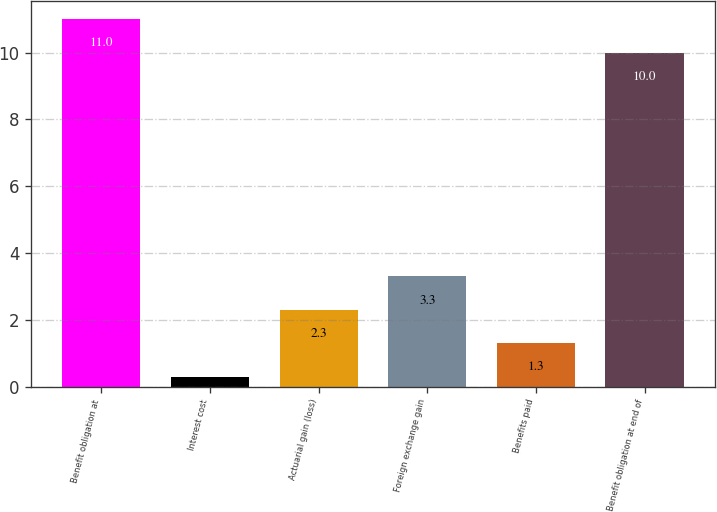Convert chart. <chart><loc_0><loc_0><loc_500><loc_500><bar_chart><fcel>Benefit obligation at<fcel>Interest cost<fcel>Actuarial gain (loss)<fcel>Foreign exchange gain<fcel>Benefits paid<fcel>Benefit obligation at end of<nl><fcel>11<fcel>0.3<fcel>2.3<fcel>3.3<fcel>1.3<fcel>10<nl></chart> 